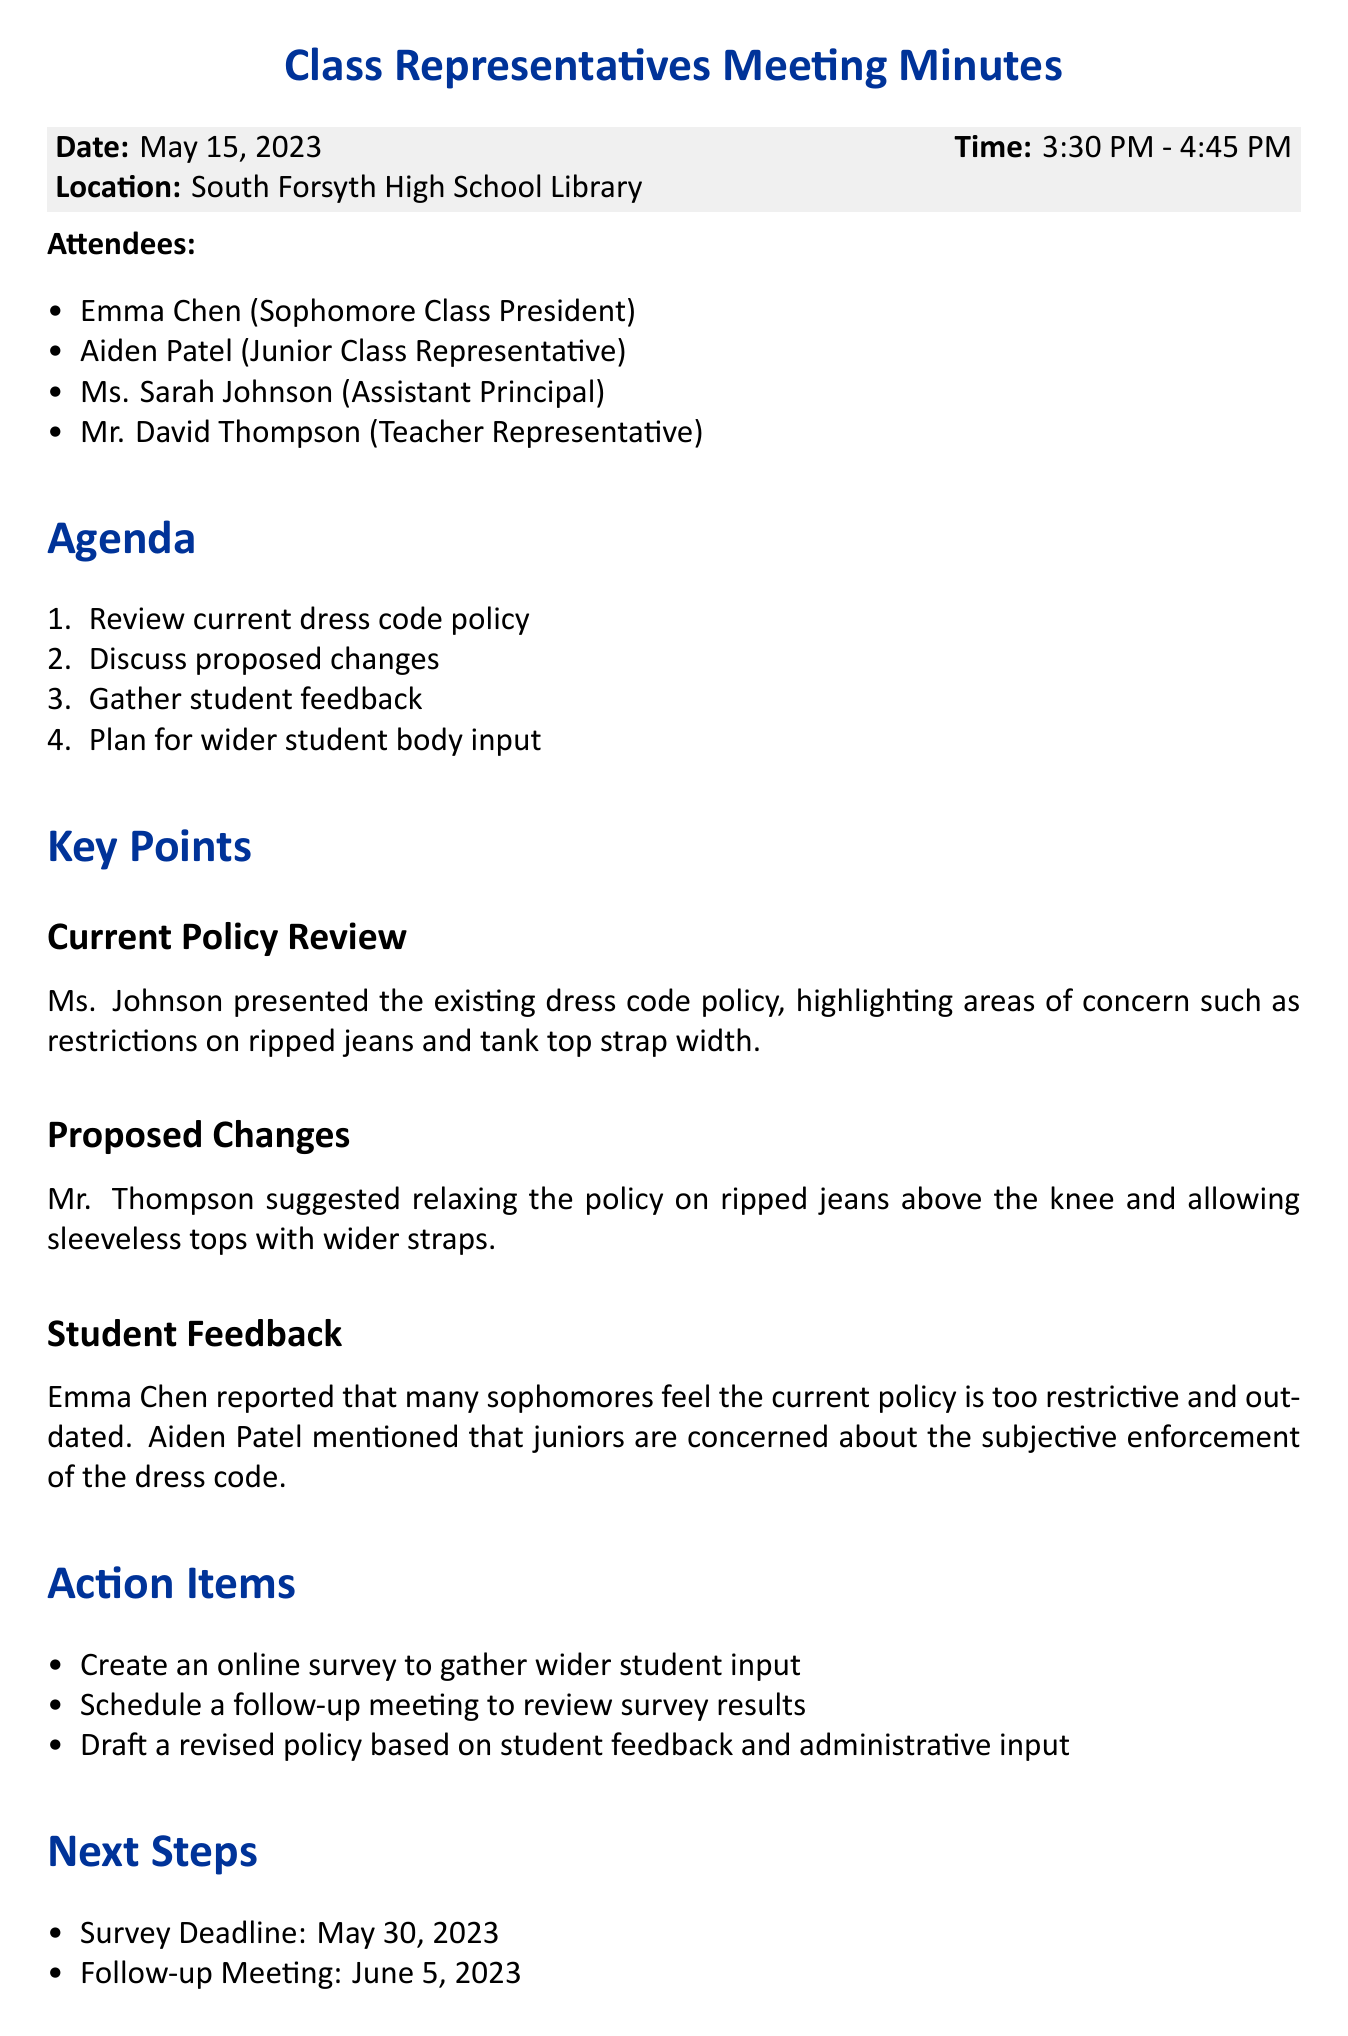What is the date of the meeting? The date of the meeting is stated clearly in the meeting details section.
Answer: May 15, 2023 Who presented the current dress code policy? The key points section indicates that Ms. Johnson presented the existing dress code policy.
Answer: Ms. Johnson What are the proposed changes to the dress code? The proposed changes are specified in the key points section under proposed changes.
Answer: Relaxing the policy on ripped jeans above the knee and allowing sleeveless tops with wider straps What feedback did Emma Chen report from sophomores? This information is included in the student feedback part of the document.
Answer: Current policy is too restrictive and outdated When is the survey deadline? The next steps section mentions the deadline for the survey.
Answer: May 30, 2023 Why are juniors concerned about the dress code? The context for juniors' concern is clearly stated in the student feedback section.
Answer: Subjective enforcement of the dress code What action item involves scheduling a follow-up? The action items section outlines actions that require scheduling, which includes one for a follow-up.
Answer: Schedule a follow-up meeting to review survey results What is the location of the meeting? The location of the meeting is provided in the meeting details section of the document.
Answer: South Forsyth High School Library 